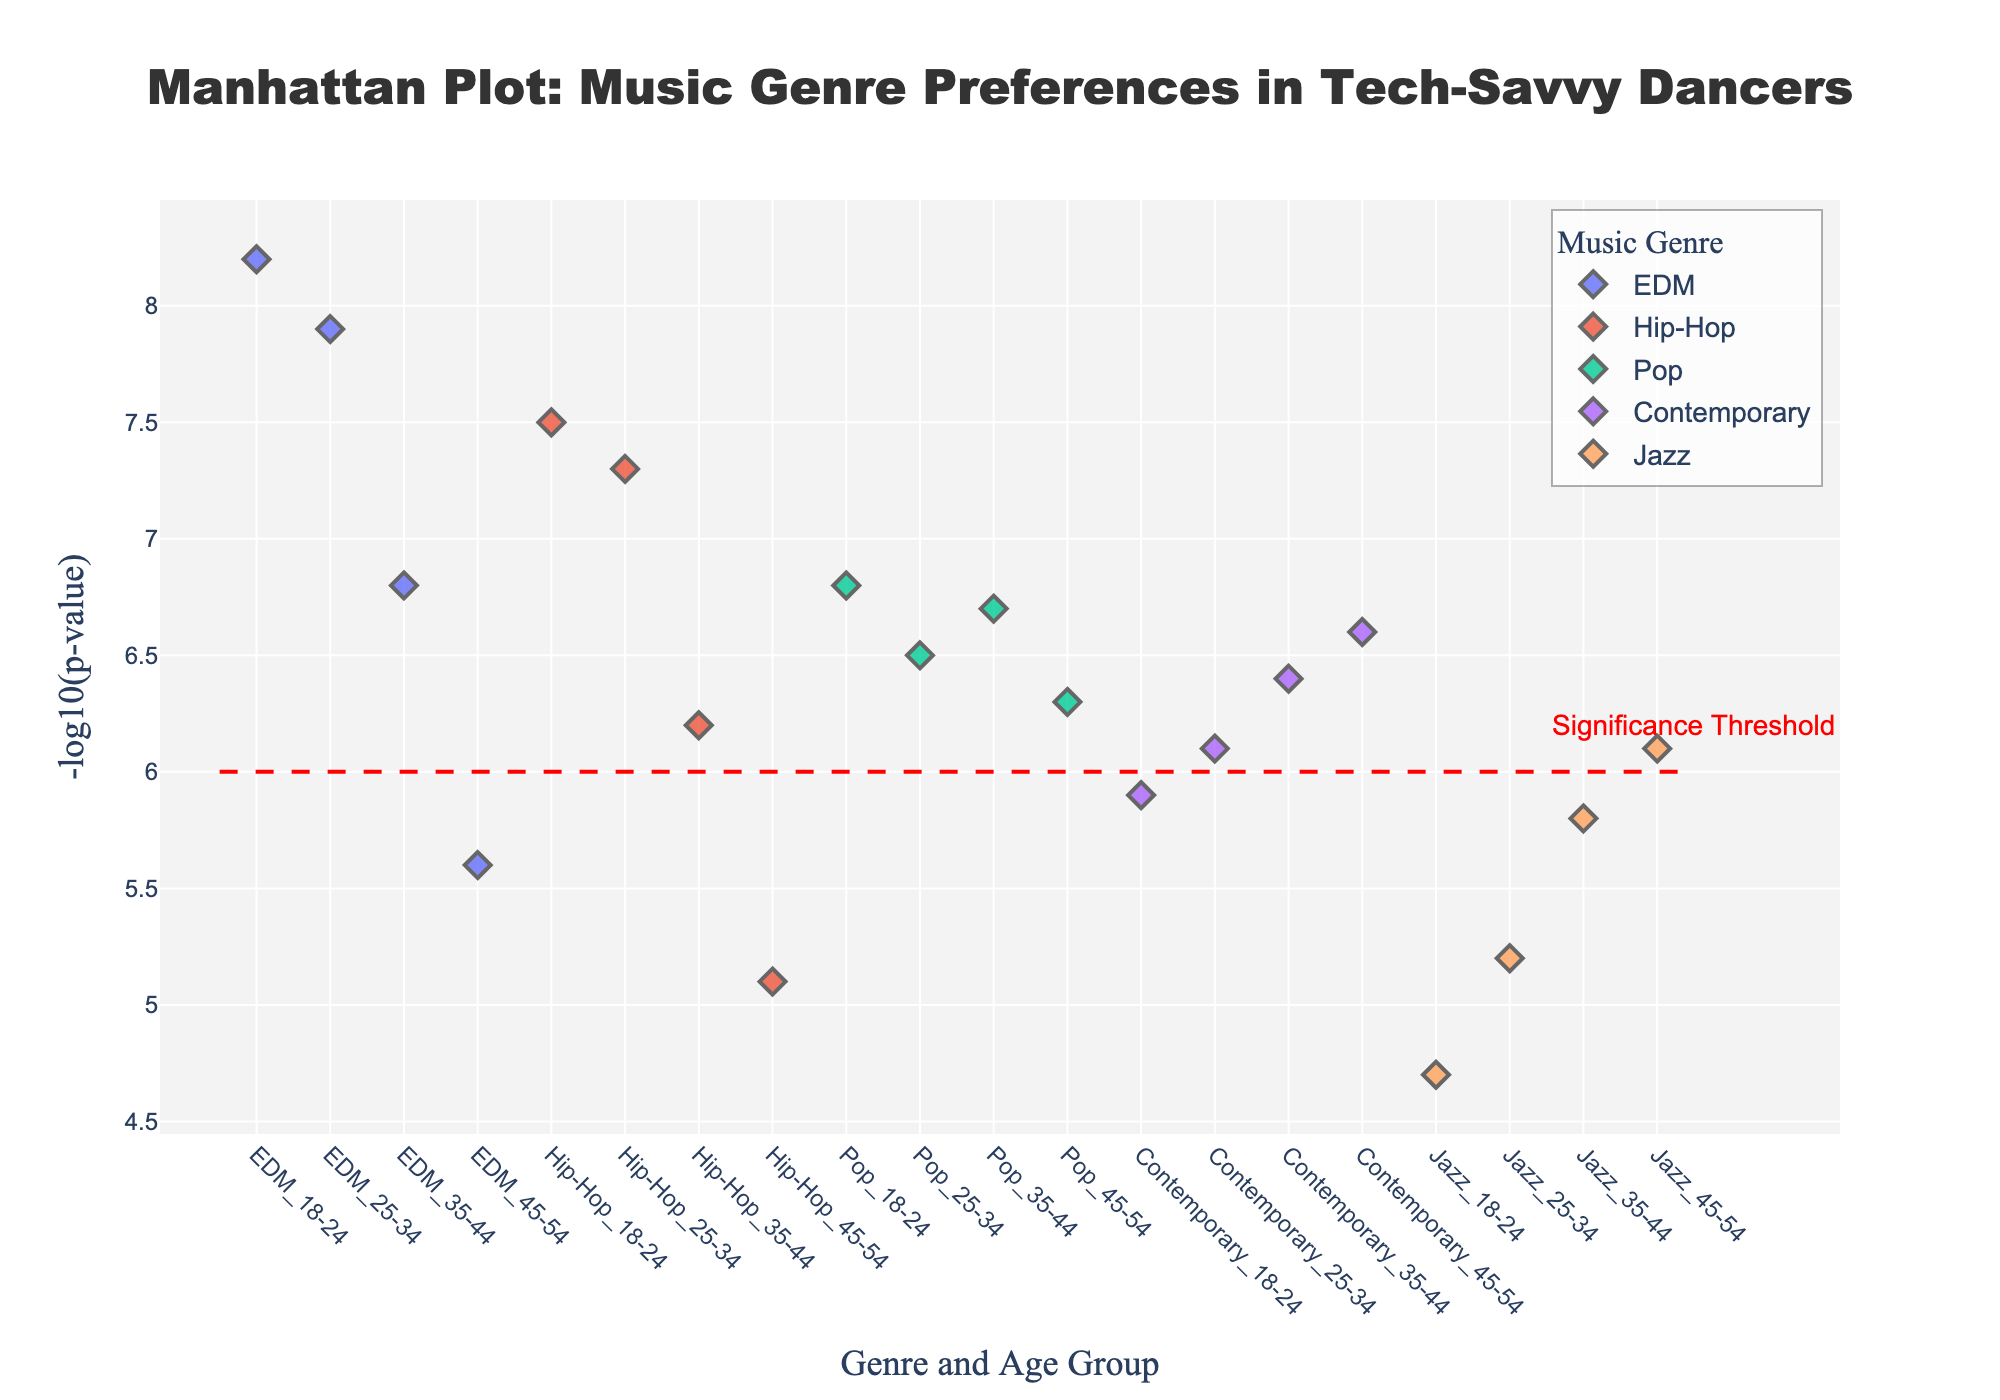What's the title of the plot? The title is prominently displayed at the top of the plot. It reads, "Manhattan Plot: Music Genre Preferences in Tech-Savvy Dancers".
Answer: Manhattan Plot: Music Genre Preferences in Tech-Savvy Dancers What do the x-axis and y-axis represent? The x-axis represents the combination of music genre and age group, while the y-axis represents the -log10(p-value) indicating the significance of the preference for each genre in each age group.
Answer: x-axis: Genre and Age Group, y-axis: -log10(p-value) Which music genre has the highest -log10(p-value) in the 18-24 age group? By looking at the data points for the 18-24 age group, EDM has the highest -log10(p-value) of 8.2, which is the highest point in that age group.
Answer: EDM How many music genres have a -log10(p-value) above the significance threshold (y=6) for the 35-44 age group? By examining the points for the 35-44 age group, we see that EDM, Hip-Hop, Pop, and Contemporary have values above the significance threshold line at y=6. Four genres meet this criterion.
Answer: 4 Which age group has the highest overall significance for EDM? The highest point for EDM across all age groups is in the 18-24 age group with a -log10(p-value) of 8.2.
Answer: 18-24 Compare the significance of Jazz preference across different age groups. Which group shows the highest significance? By comparing the -log10(p-values) of Jazz across age groups (18-24: 4.7, 25-34: 5.2, 35-44: 5.8, 45-54: 6.1), the 45-54 age group has the highest -log10(p-value) of 6.1.
Answer: 45-54 Is there any music genre that is preferred equally by any two age groups based on the -log10(p-value)? The -log10(p-values) across music genres and age groups are all distinct, so no genre is equally preferred by two age groups.
Answer: No Which age group shows the least preference for Pop music? The smallest -log10(p-value) for Pop music is in the 25-34 age group with a value of 6.5.
Answer: 25-34 Calculate the average -log10(p-value) of Contemporary music across all age groups. The values are 18-24: 5.9, 25-34: 6.1, 35-44: 6.4, 45-54: 6.6. Sum these (5.9 + 6.1 + 6.4 + 6.6 = 25) and divide by 4 (number of age groups), yielding an average of 25/4 = 6.25.
Answer: 6.25 